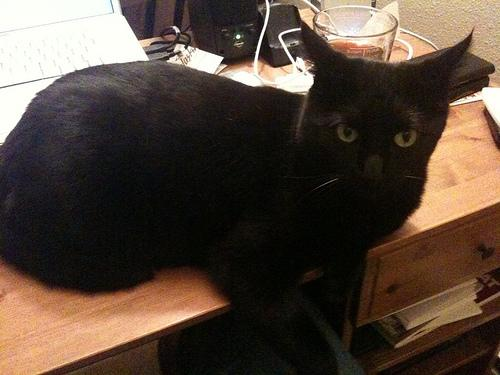What type of woman might this animal be associated with historically?

Choices:
A) wetnurse
B) midwife
C) witch
D) nurse witch 